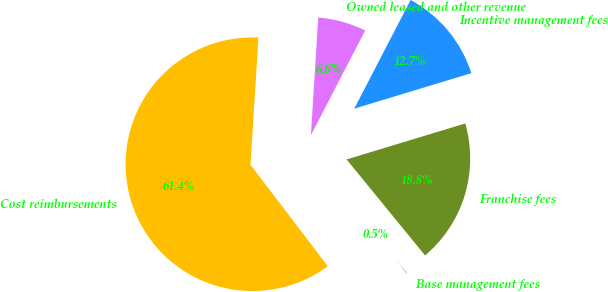<chart> <loc_0><loc_0><loc_500><loc_500><pie_chart><fcel>Base management fees<fcel>Franchise fees<fcel>Incentive management fees<fcel>Owned leased and other revenue<fcel>Cost reimbursements<nl><fcel>0.54%<fcel>18.78%<fcel>12.7%<fcel>6.62%<fcel>61.35%<nl></chart> 